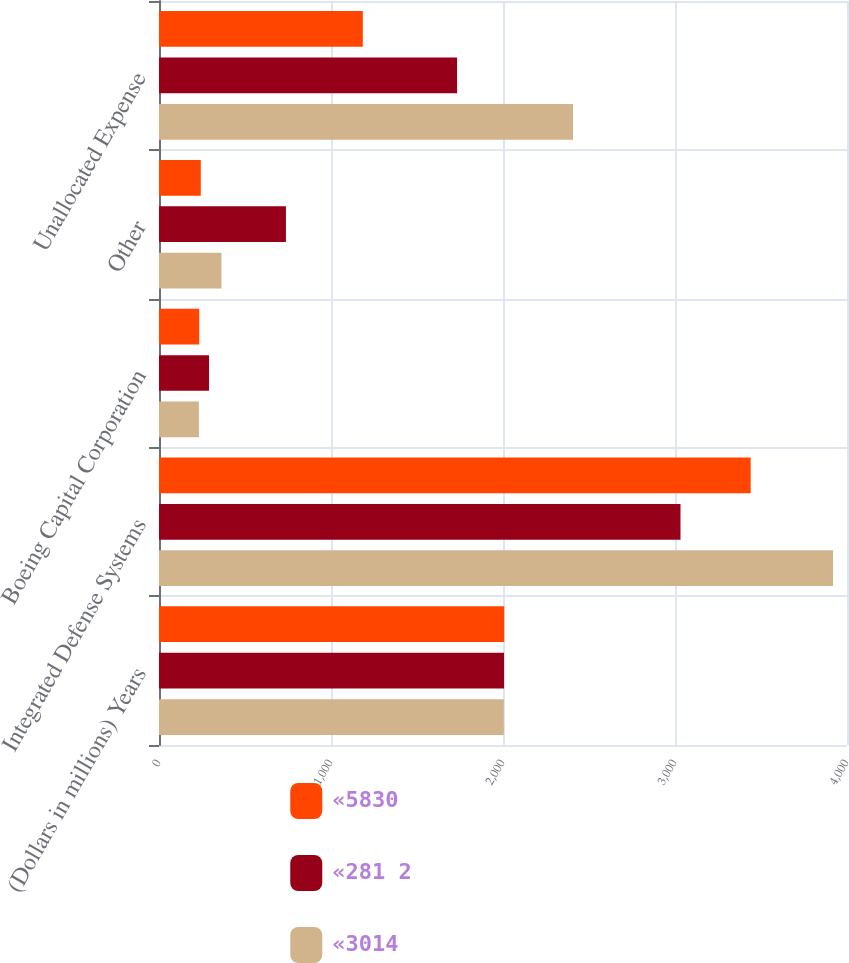Convert chart to OTSL. <chart><loc_0><loc_0><loc_500><loc_500><stacked_bar_chart><ecel><fcel>(Dollars in millions) Years<fcel>Integrated Defense Systems<fcel>Boeing Capital Corporation<fcel>Other<fcel>Unallocated Expense<nl><fcel>«5830<fcel>2007<fcel>3440<fcel>234<fcel>243<fcel>1185<nl><fcel>«281 2<fcel>2006<fcel>3032<fcel>291<fcel>738<fcel>1733<nl><fcel>«3014<fcel>2005<fcel>3919<fcel>232<fcel>363<fcel>2407<nl></chart> 